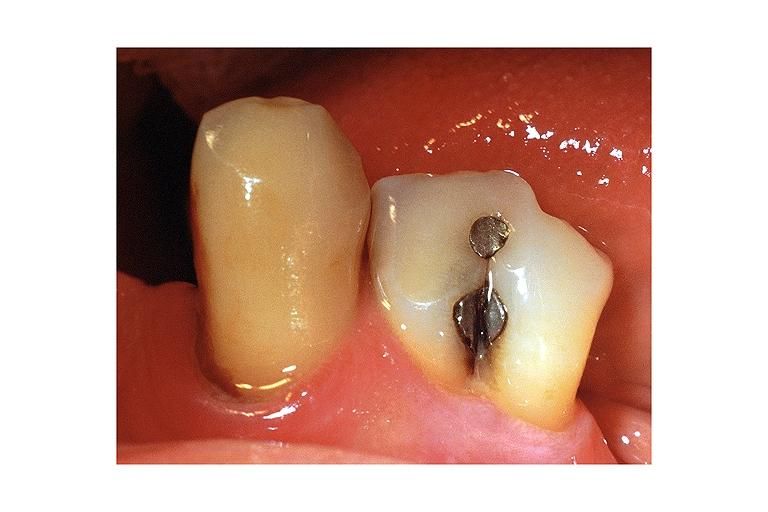does this image show fusion?
Answer the question using a single word or phrase. Yes 